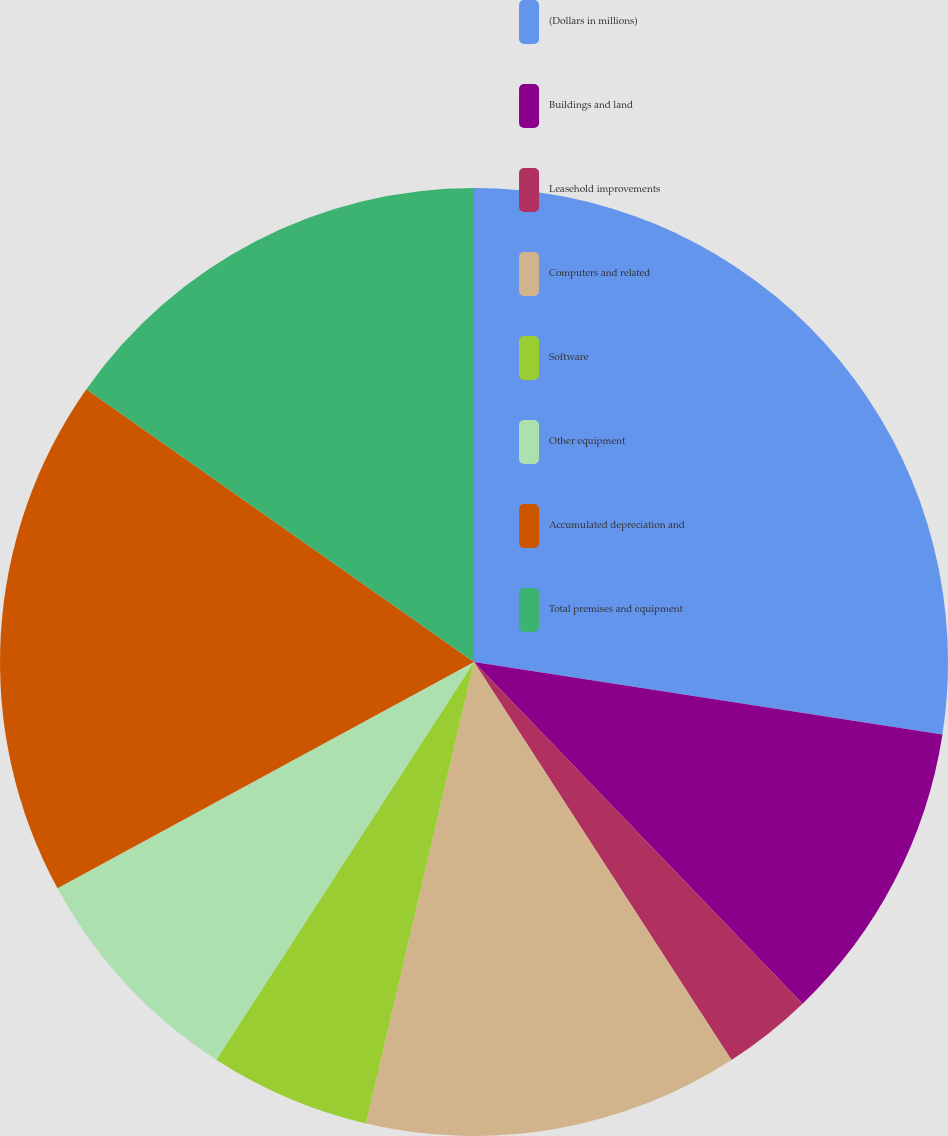Convert chart to OTSL. <chart><loc_0><loc_0><loc_500><loc_500><pie_chart><fcel>(Dollars in millions)<fcel>Buildings and land<fcel>Leasehold improvements<fcel>Computers and related<fcel>Software<fcel>Other equipment<fcel>Accumulated depreciation and<fcel>Total premises and equipment<nl><fcel>27.44%<fcel>10.37%<fcel>3.05%<fcel>12.8%<fcel>5.49%<fcel>7.93%<fcel>17.68%<fcel>15.24%<nl></chart> 